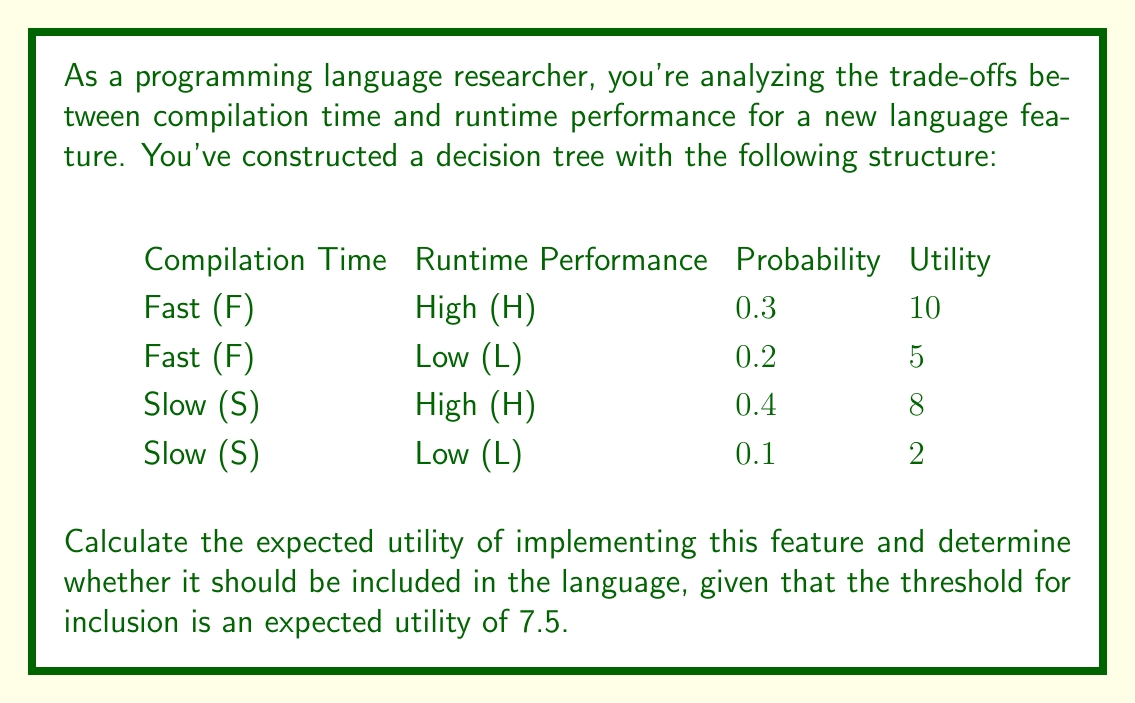Help me with this question. To solve this problem, we need to calculate the expected utility using the decision tree provided. We'll follow these steps:

1. Calculate the utility for each outcome:
   - Fast compilation, High performance: $U(F,H) = 10$
   - Fast compilation, Low performance: $U(F,L) = 5$
   - Slow compilation, High performance: $U(S,H) = 8$
   - Slow compilation, Low performance: $U(S,L) = 2$

2. Multiply each utility by its corresponding probability:
   - $E(F,H) = 0.3 \times 10 = 3$
   - $E(F,L) = 0.2 \times 5 = 1$
   - $E(S,H) = 0.4 \times 8 = 3.2$
   - $E(S,L) = 0.1 \times 2 = 0.2$

3. Sum up all the expected utilities:
   $$E(\text{total}) = E(F,H) + E(F,L) + E(S,H) + E(S,L)$$
   $$E(\text{total}) = 3 + 1 + 3.2 + 0.2 = 7.4$$

4. Compare the total expected utility to the threshold:
   The expected utility (7.4) is less than the threshold for inclusion (7.5).

Therefore, based on this analysis, the feature should not be included in the language as its expected utility falls below the required threshold.
Answer: The expected utility is 7.4, which is below the threshold of 7.5. Therefore, the feature should not be included in the language. 